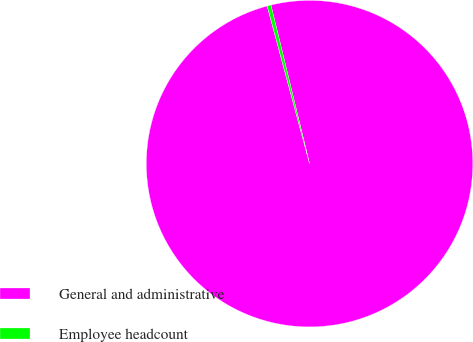Convert chart. <chart><loc_0><loc_0><loc_500><loc_500><pie_chart><fcel>General and administrative<fcel>Employee headcount<nl><fcel>99.62%<fcel>0.38%<nl></chart> 